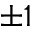<formula> <loc_0><loc_0><loc_500><loc_500>\pm 1</formula> 